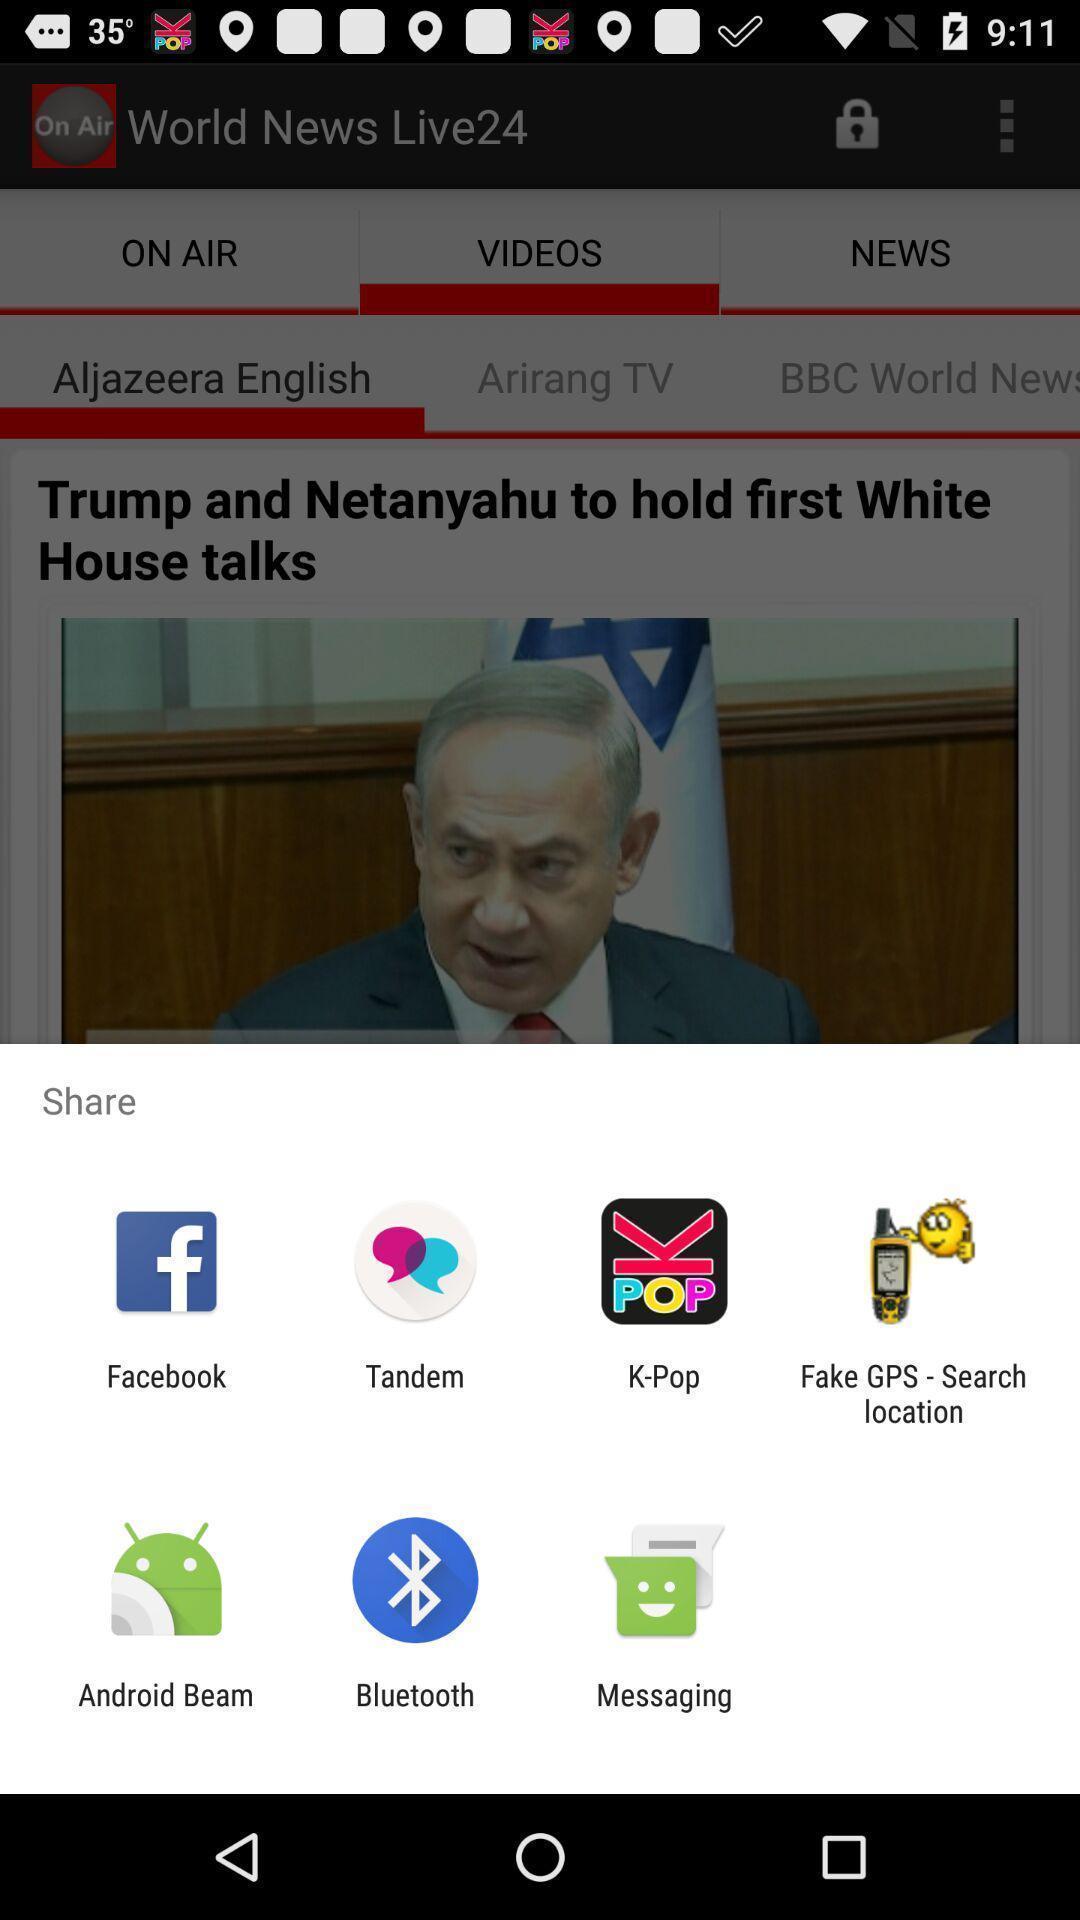What details can you identify in this image? Video sharing with different apps. 